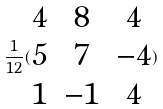Convert formula to latex. <formula><loc_0><loc_0><loc_500><loc_500>\frac { 1 } { 1 2 } ( \begin{matrix} 4 & 8 & 4 \\ 5 & 7 & - 4 \\ 1 & - 1 & 4 \end{matrix} )</formula> 